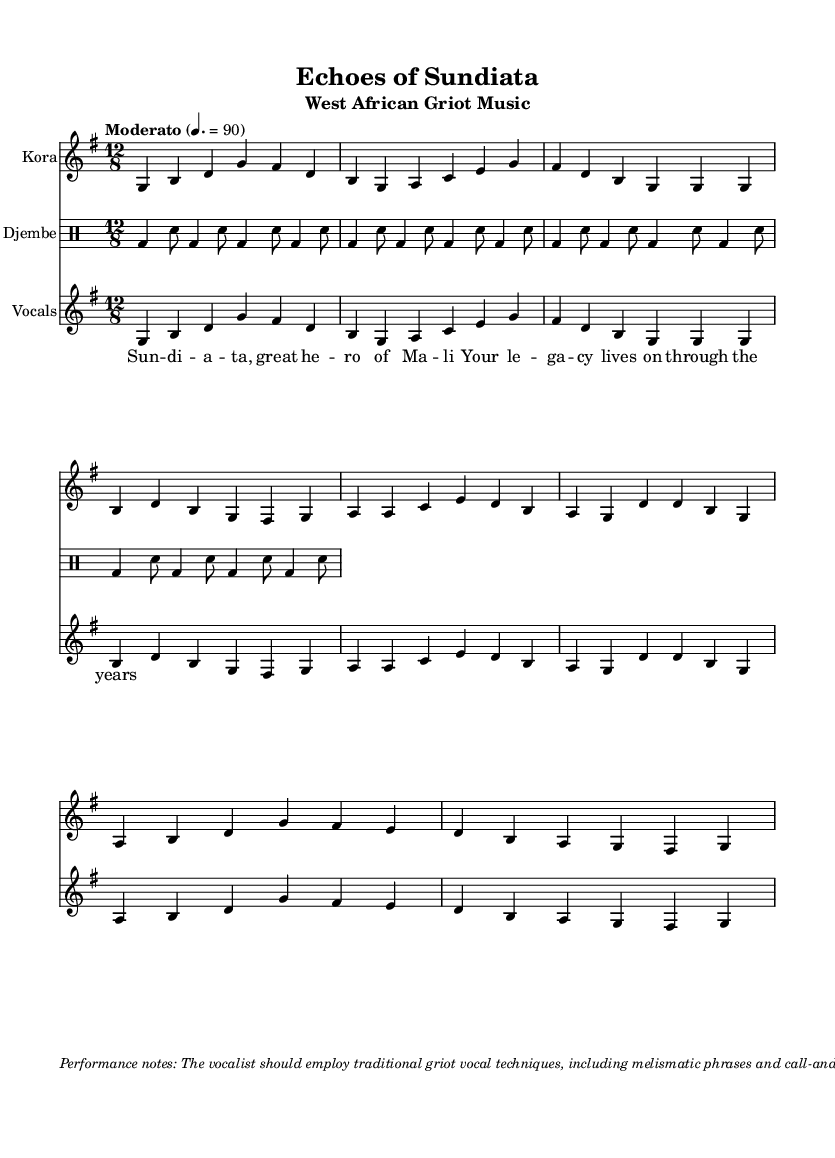What is the key signature of this music? The key signature is G major, identifiable by one sharp (F#) noted next to the staff.
Answer: G major What is the time signature of this music? The time signature is 12/8, visible as a notation on the left side of the staff indicating 12 beats per measure, grouped into four sets of three.
Answer: 12/8 What is the tempo marking in BPM? The tempo marking indicates a speed of 90 beats per minute, as shown above the score in the tempo instruction.
Answer: 90 How many measures are in the introduction section? By counting the measures in the introduction part of the kora music, there are 2 measures before the verse begins.
Answer: 2 What is the primary instrument used in this piece? The primary instrument is the kora, explicitly noted as the instrument name in the staff for the corresponding music section.
Answer: Kora Which vocal technique is emphasized in the performance notes? The performance notes emphasize the use of melismatic phrases, which involve singing multiple notes for a single syllable.
Answer: Melismatic phrases What is the main cultural significance of the piece? This piece narrates the legacy of Sundiata, identified as a great hero of Mali, which showcases the griot's role in preserving cultural history through music.
Answer: Sundiata 